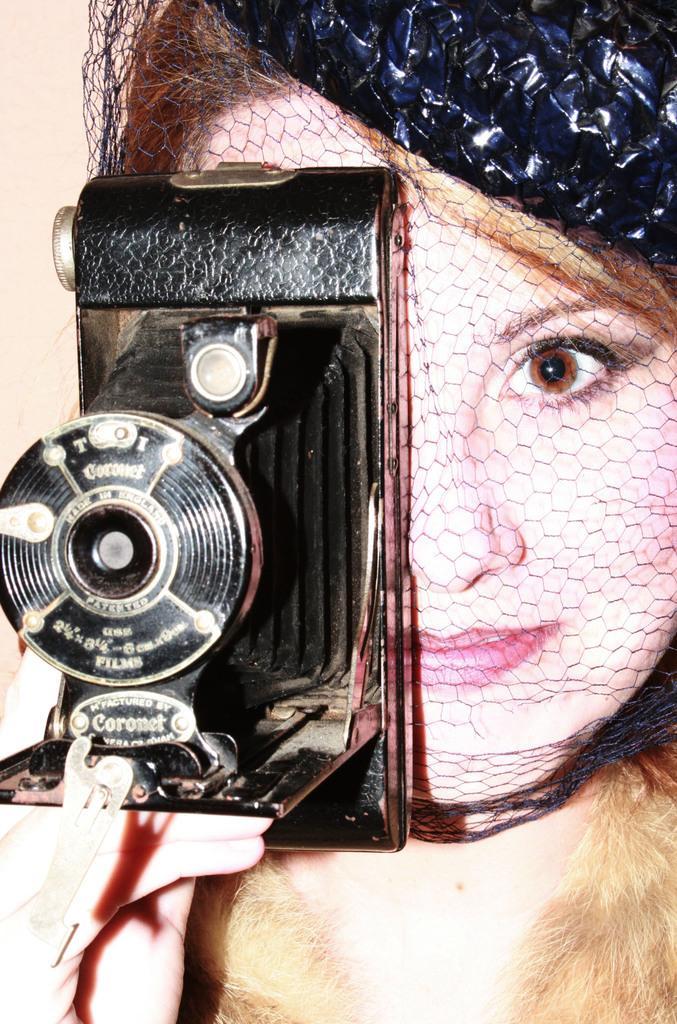Please provide a concise description of this image. This is the picture of a lady holding a camera in her right hand and covering her right eye. 